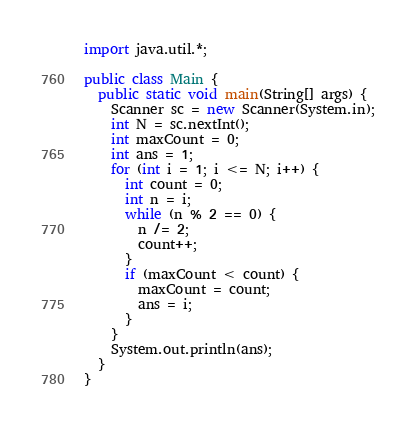<code> <loc_0><loc_0><loc_500><loc_500><_Java_>import java.util.*;

public class Main {
  public static void main(String[] args) {
    Scanner sc = new Scanner(System.in);
    int N = sc.nextInt();
    int maxCount = 0;
    int ans = 1;
    for (int i = 1; i <= N; i++) {
      int count = 0;
      int n = i;
      while (n % 2 == 0) {
        n /= 2;
        count++;
      }
      if (maxCount < count) {
        maxCount = count;
        ans = i;
      }
    }
    System.out.println(ans);
  }
}</code> 